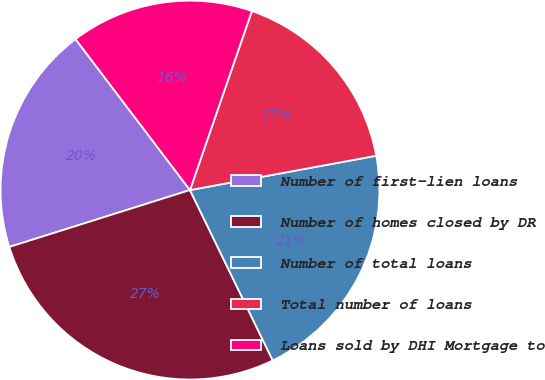<chart> <loc_0><loc_0><loc_500><loc_500><pie_chart><fcel>Number of first-lien loans<fcel>Number of homes closed by DR<fcel>Number of total loans<fcel>Total number of loans<fcel>Loans sold by DHI Mortgage to<nl><fcel>19.53%<fcel>27.34%<fcel>20.7%<fcel>16.8%<fcel>15.62%<nl></chart> 